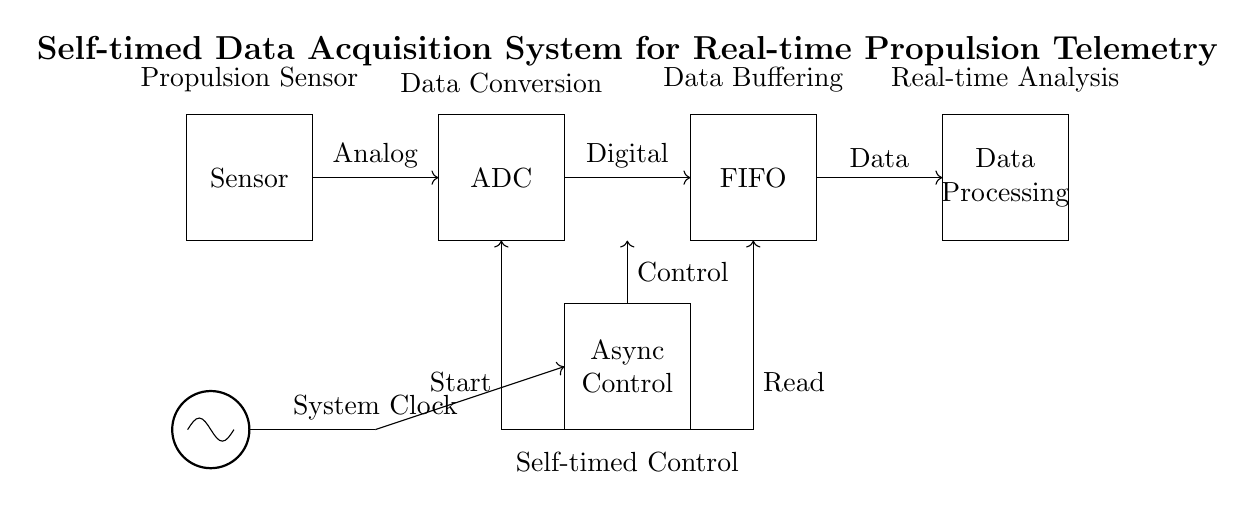What is the primary function of the sensor in this circuit? The sensor's primary function is to capture real-time data related to propulsion parameters, converting physical quantities into an analog signal for further processing.
Answer: Capture real-time data What type of data does the ADC convert? The ADC (Analog-to-Digital Converter) converts analog signals from the sensor into digital data, suitable for further processing and analysis.
Answer: Analog to digital How many main blocks are in this circuit? The circuit contains five main blocks: Sensor, ADC, FIFO, Async Control, and Data Processing, which work together for data acquisition and processing.
Answer: Five What is the role of the FIFO buffer in this diagram? The FIFO (First In, First Out) buffer temporarily stores data from the ADC before it is sent to the data processing unit, ensuring organized and timed data flow.
Answer: Temporary data storage What does the clock symbol indicate in this circuit? The clock symbol indicates that the circuit operates with a timing signal, coordinating the asynchronous control signals and the overall data acquisition process.
Answer: Timing signal Which component controls the asynchronous operation of the circuit? The asynchronous control logic block manages the control signals for the timing and processing of data, allowing for non-synchronous operations between components.
Answer: Async Control What type of signals does the control logic send to the ADC? The control logic sends signals that initiate the data conversion process, specifically a "Start" signal which triggers the ADC to begin transforming analog data into digital form.
Answer: Start signals 